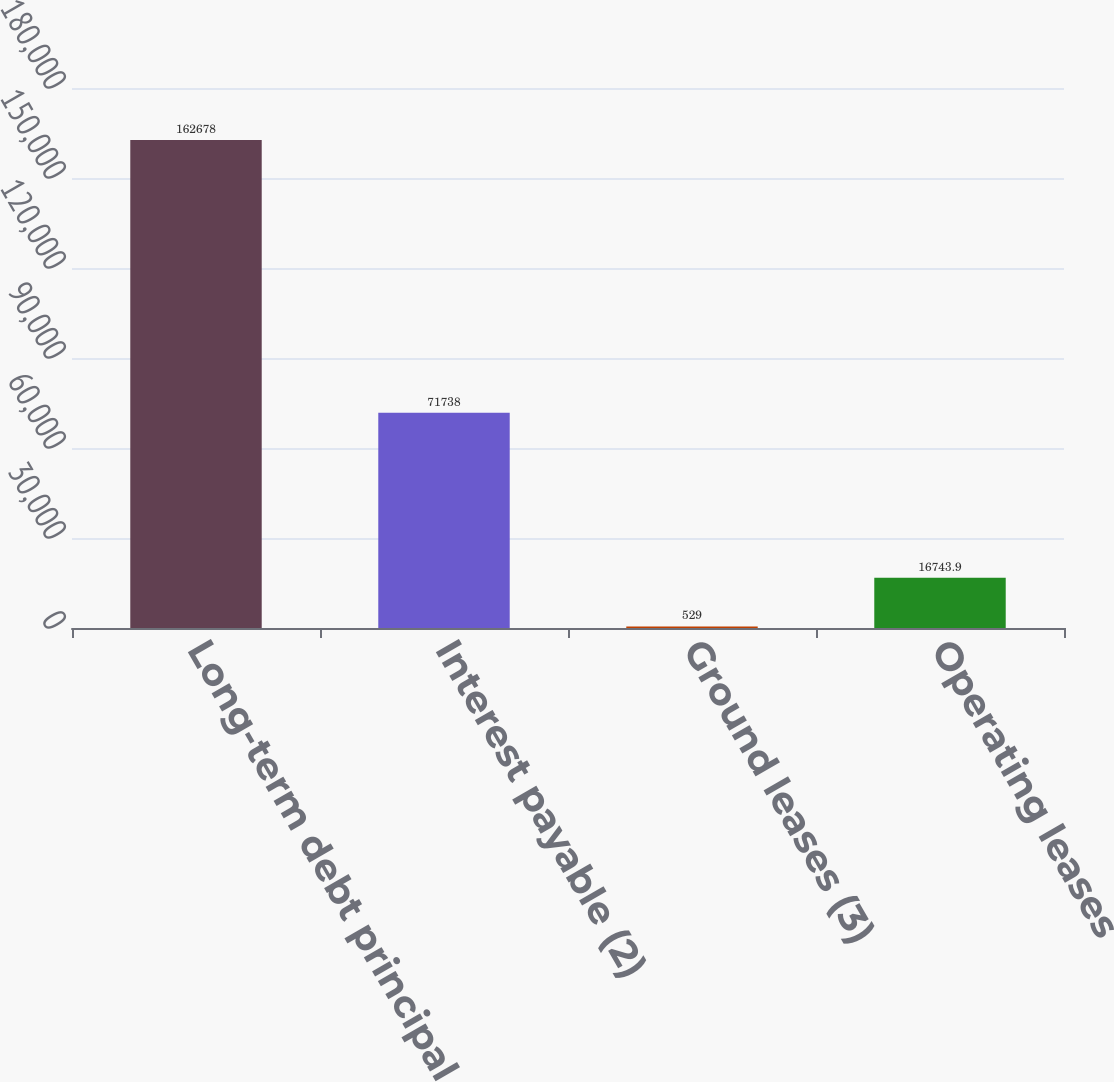Convert chart to OTSL. <chart><loc_0><loc_0><loc_500><loc_500><bar_chart><fcel>Long-term debt principal<fcel>Interest payable (2)<fcel>Ground leases (3)<fcel>Operating leases<nl><fcel>162678<fcel>71738<fcel>529<fcel>16743.9<nl></chart> 